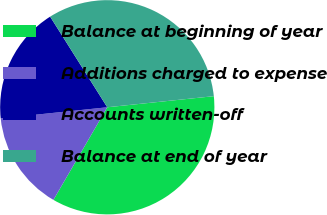Convert chart to OTSL. <chart><loc_0><loc_0><loc_500><loc_500><pie_chart><fcel>Balance at beginning of year<fcel>Additions charged to expense<fcel>Accounts written-off<fcel>Balance at end of year<nl><fcel>35.03%<fcel>14.97%<fcel>17.7%<fcel>32.3%<nl></chart> 